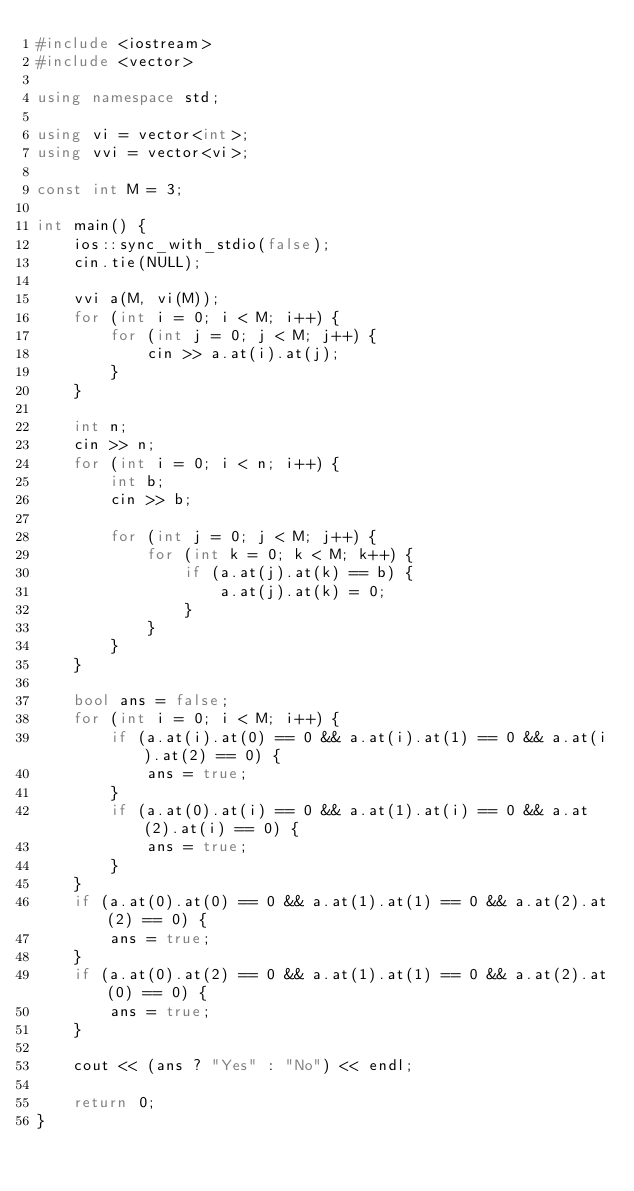<code> <loc_0><loc_0><loc_500><loc_500><_C++_>#include <iostream>
#include <vector>

using namespace std;

using vi = vector<int>;
using vvi = vector<vi>;

const int M = 3;

int main() {
    ios::sync_with_stdio(false);
    cin.tie(NULL);

    vvi a(M, vi(M));
    for (int i = 0; i < M; i++) {
        for (int j = 0; j < M; j++) {
            cin >> a.at(i).at(j);
        }
    }

    int n;
    cin >> n;
    for (int i = 0; i < n; i++) {
        int b;
        cin >> b;

        for (int j = 0; j < M; j++) {
            for (int k = 0; k < M; k++) {
                if (a.at(j).at(k) == b) {
                    a.at(j).at(k) = 0;
                }
            }
        }
    }

    bool ans = false;
    for (int i = 0; i < M; i++) {
        if (a.at(i).at(0) == 0 && a.at(i).at(1) == 0 && a.at(i).at(2) == 0) {
            ans = true;
        }
        if (a.at(0).at(i) == 0 && a.at(1).at(i) == 0 && a.at(2).at(i) == 0) {
            ans = true;
        }
    }
    if (a.at(0).at(0) == 0 && a.at(1).at(1) == 0 && a.at(2).at(2) == 0) {
        ans = true;
    }
    if (a.at(0).at(2) == 0 && a.at(1).at(1) == 0 && a.at(2).at(0) == 0) {
        ans = true;
    }

    cout << (ans ? "Yes" : "No") << endl;

    return 0;
}
</code> 